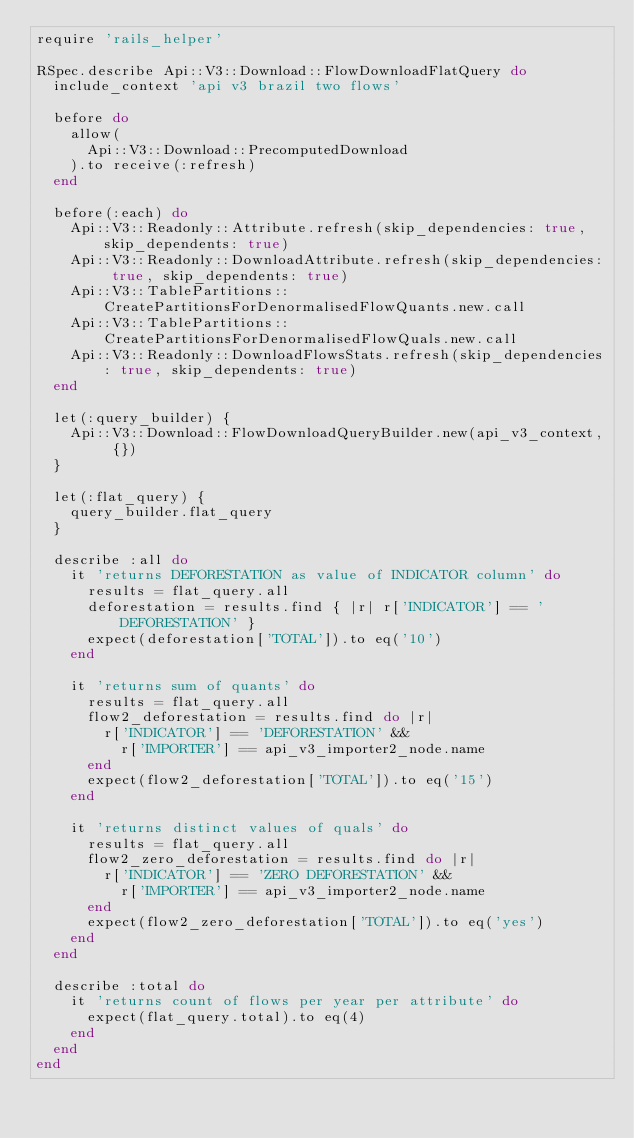<code> <loc_0><loc_0><loc_500><loc_500><_Ruby_>require 'rails_helper'

RSpec.describe Api::V3::Download::FlowDownloadFlatQuery do
  include_context 'api v3 brazil two flows'

  before do
    allow(
      Api::V3::Download::PrecomputedDownload
    ).to receive(:refresh)
  end

  before(:each) do
    Api::V3::Readonly::Attribute.refresh(skip_dependencies: true, skip_dependents: true)
    Api::V3::Readonly::DownloadAttribute.refresh(skip_dependencies: true, skip_dependents: true)
    Api::V3::TablePartitions::CreatePartitionsForDenormalisedFlowQuants.new.call
    Api::V3::TablePartitions::CreatePartitionsForDenormalisedFlowQuals.new.call
    Api::V3::Readonly::DownloadFlowsStats.refresh(skip_dependencies: true, skip_dependents: true)
  end

  let(:query_builder) {
    Api::V3::Download::FlowDownloadQueryBuilder.new(api_v3_context, {})
  }

  let(:flat_query) {
    query_builder.flat_query
  }

  describe :all do
    it 'returns DEFORESTATION as value of INDICATOR column' do
      results = flat_query.all
      deforestation = results.find { |r| r['INDICATOR'] == 'DEFORESTATION' }
      expect(deforestation['TOTAL']).to eq('10')
    end

    it 'returns sum of quants' do
      results = flat_query.all
      flow2_deforestation = results.find do |r|
        r['INDICATOR'] == 'DEFORESTATION' &&
          r['IMPORTER'] == api_v3_importer2_node.name
      end
      expect(flow2_deforestation['TOTAL']).to eq('15')
    end

    it 'returns distinct values of quals' do
      results = flat_query.all
      flow2_zero_deforestation = results.find do |r|
        r['INDICATOR'] == 'ZERO DEFORESTATION' &&
          r['IMPORTER'] == api_v3_importer2_node.name
      end
      expect(flow2_zero_deforestation['TOTAL']).to eq('yes')
    end
  end

  describe :total do
    it 'returns count of flows per year per attribute' do
      expect(flat_query.total).to eq(4)
    end
  end
end
</code> 